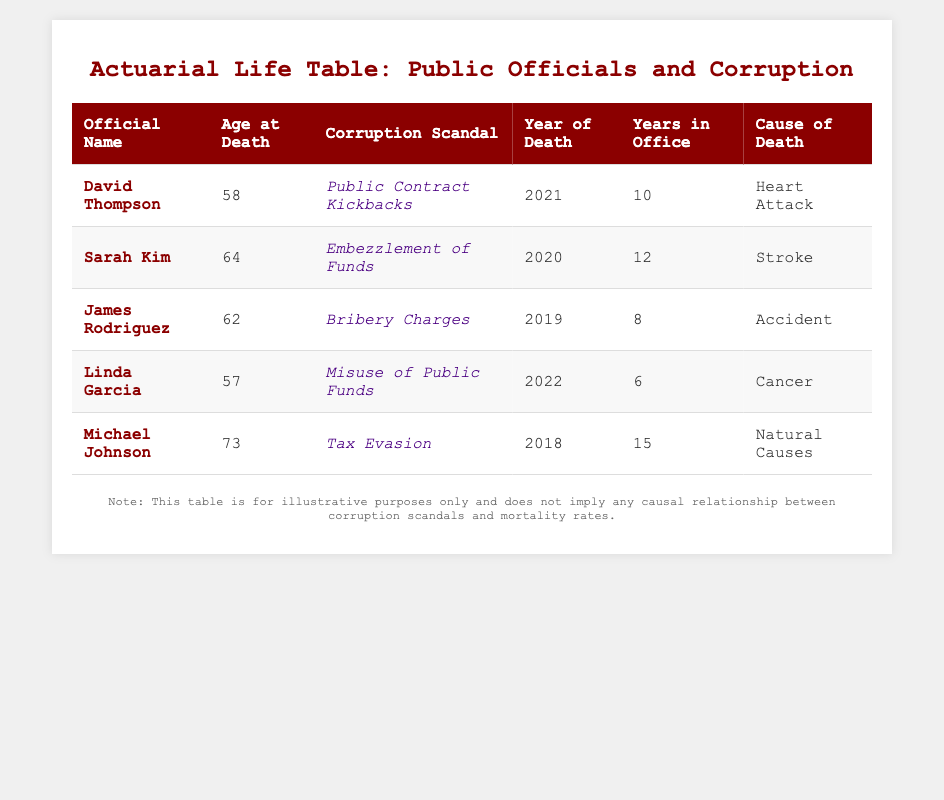What is the age at death of Linda Garcia? Linda Garcia's age at death is listed in the table under the "Age at Death" column, where it states she died at 57 years old.
Answer: 57 How many years did Michael Johnson serve in office? The table shows that Michael Johnson served in office for 15 years, which is indicated in the "Years in Office" column.
Answer: 15 Which official died in 2021? By checking the "Year of Death" column, we see that David Thompson died in 2021, as indicated directly in that column.
Answer: David Thompson What is the average age at death for all officials listed? To find the average, we first sum the ages at death: (58 + 64 + 62 + 57 + 73) = 314. Then we divide by the number of officials, which is 5. So the average is 314/5 = 62.8.
Answer: 62.8 Did any official die from natural causes? Referring to the "Cause of Death" column, Michael Johnson's cause of death is listed as "Natural Causes," confirming that at least one official did die this way.
Answer: Yes What is the total number of years in office for all the officials? We add the years in office for each official: (10 + 12 + 8 + 6 + 15) = 51. Thus, the total number of years in office for all officials combined is 51.
Answer: 51 Who was implicated in the largest number of years in office before their death? Michael Johnson served 15 years in office, which is the highest number compared to others. Checking all entries, he is the only official with this length of service.
Answer: Michael Johnson Which corruption scandal involved the youngest official at the time of death? To find the youngest official, we look for the minimum value in the "Age at Death" column, which is 57, corresponding to Linda Garcia who was implicated in the "Misuse of Public Funds" scandal.
Answer: Misuse of Public Funds How many officials died from cardiovascular-related causes? Checking the "Cause of Death" column, both David Thompson (Heart Attack) and Sarah Kim (Stroke) had cardiovascular-related causes. Thus, there are two officials who died this way.
Answer: 2 